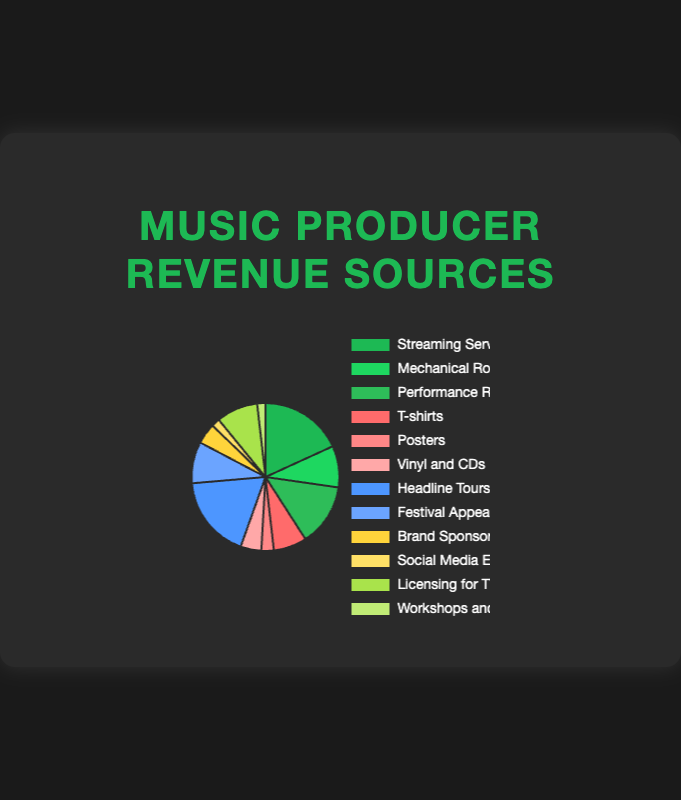What is the largest revenue source for music producers in the chart? The largest revenue source can be identified by comparing the size of the sections in the pie chart. The largest section represents "Headline Tours" with 20%.
Answer: Headline Tours What percentage of revenue comes from merchandise sales, and which specific entity contributes the most within this source? To find the percentage of revenue from merchandise, add the percentages for T-shirts (8%), Posters (3%), and Vinyl and CDs (5%). T-shirts contribute the most within merchandise.
Answer: 16%, T-shirts How does the revenue from Streaming Services compare to the revenue from Licensing for TV/Film? Find the percentage for Streaming Services (20%) and compare it to Licensing for TV/Film (10%). Streaming Services have a higher percentage.
Answer: Streaming Services is higher What is the combined revenue percentage from social media endorsements and brand sponsorships? To find the combined total, add the percentages of Social Media Endorsements (2%) and Brand Sponsorships (5%). The result is 2% + 5% = 7%.
Answer: 7% Which revenue source has the smallest share, and what is its percentage? The smallest section in the pie chart corresponds to Social Media Endorsements with a percentage of 2%.
Answer: Social Media Endorsements, 2% How much more revenue is generated from Performance Rights compared to Posters? Find the percentages of Performance Rights (15%) and Posters (3%), then subtract the smaller value from the larger one. 15% - 3% = 12%.
Answer: 12% What are the total contributions of tours and merchandise to the overall revenue? Calculate the total by adding the percentages from headline tours (20%), festival appearances (10%), T-shirts (8%), Posters (3%), and Vinyl and CDs (5%). The total is 20% + 10% + 8% + 3% + 5% = 46%.
Answer: 46% Is revenue from mechanical royalties higher than from T-shirts? Compare the percentages for Mechanical Royalties (10%) and T-shirts (8%). Mechanical Royalties have a higher percentage.
Answer: Yes 